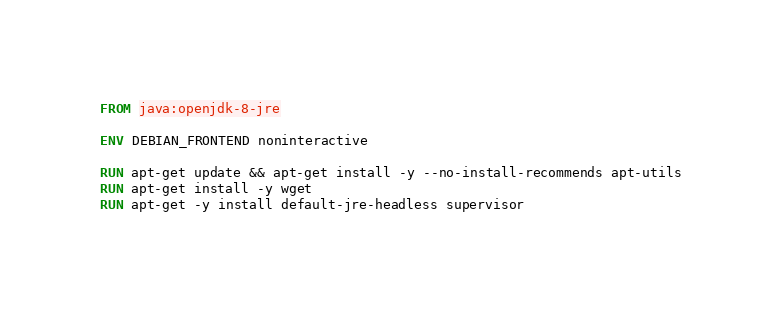Convert code to text. <code><loc_0><loc_0><loc_500><loc_500><_Dockerfile_>FROM java:openjdk-8-jre

ENV DEBIAN_FRONTEND noninteractive

RUN apt-get update && apt-get install -y --no-install-recommends apt-utils
RUN apt-get install -y wget
RUN apt-get -y install default-jre-headless supervisor
</code> 